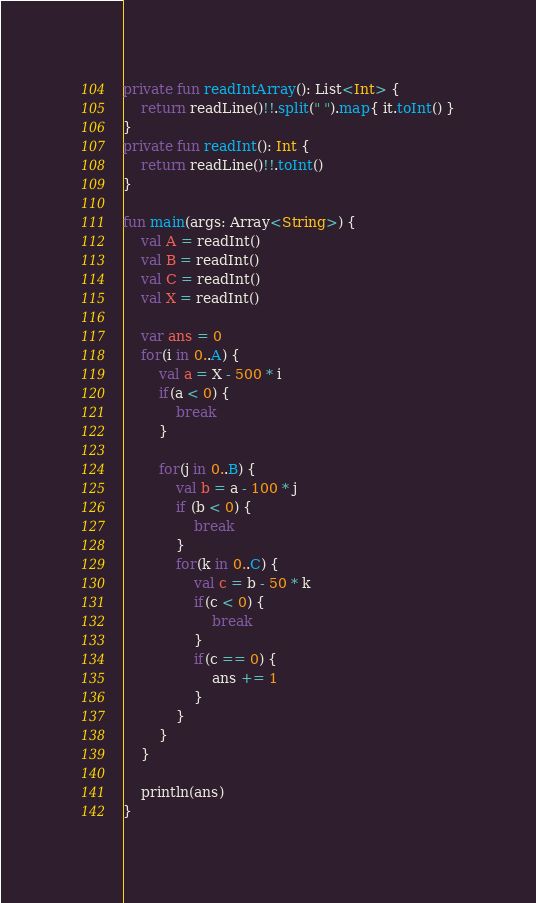Convert code to text. <code><loc_0><loc_0><loc_500><loc_500><_Kotlin_>private fun readIntArray(): List<Int> {
    return readLine()!!.split(" ").map{ it.toInt() }
}
private fun readInt(): Int {
    return readLine()!!.toInt()
}

fun main(args: Array<String>) {
    val A = readInt()
    val B = readInt()
    val C = readInt()
    val X = readInt()

    var ans = 0
    for(i in 0..A) {
        val a = X - 500 * i
        if(a < 0) {
            break
        }

        for(j in 0..B) {
            val b = a - 100 * j
            if (b < 0) {
                break
            }
            for(k in 0..C) {
                val c = b - 50 * k
                if(c < 0) {
                    break
                }
                if(c == 0) {
                    ans += 1
                }
            }
        }
    }

    println(ans)
}
</code> 